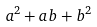<formula> <loc_0><loc_0><loc_500><loc_500>a ^ { 2 } + a b + b ^ { 2 }</formula> 